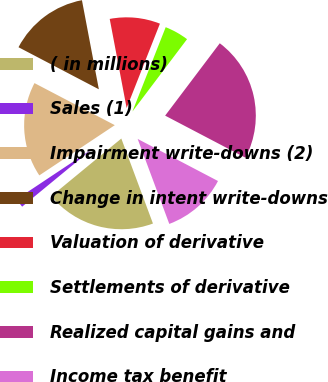Convert chart to OTSL. <chart><loc_0><loc_0><loc_500><loc_500><pie_chart><fcel>( in millions)<fcel>Sales (1)<fcel>Impairment write-downs (2)<fcel>Change in intent write-downs<fcel>Valuation of derivative<fcel>Settlements of derivative<fcel>Realized capital gains and<fcel>Income tax benefit<nl><fcel>19.71%<fcel>1.62%<fcel>17.02%<fcel>14.34%<fcel>8.97%<fcel>4.31%<fcel>22.39%<fcel>11.65%<nl></chart> 